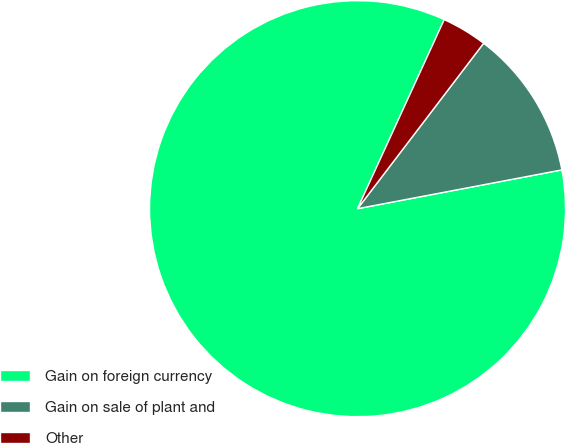Convert chart to OTSL. <chart><loc_0><loc_0><loc_500><loc_500><pie_chart><fcel>Gain on foreign currency<fcel>Gain on sale of plant and<fcel>Other<nl><fcel>84.83%<fcel>11.65%<fcel>3.52%<nl></chart> 